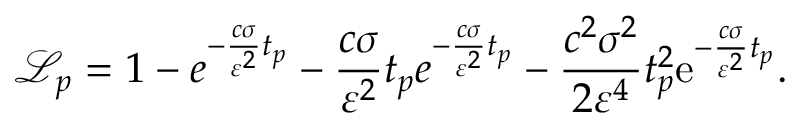<formula> <loc_0><loc_0><loc_500><loc_500>\mathcal { L } _ { p } = 1 - e ^ { - \frac { c \sigma } { \varepsilon ^ { 2 } } t _ { p } } - \frac { c \sigma } { \varepsilon ^ { 2 } } t _ { p } e ^ { - \frac { c \sigma } { \varepsilon ^ { 2 } } t _ { p } } - \frac { c ^ { 2 } \sigma ^ { 2 } } { 2 \varepsilon ^ { 4 } } t _ { p } ^ { 2 } e ^ { - \frac { c \sigma } { \varepsilon ^ { 2 } } t _ { p } } .</formula> 